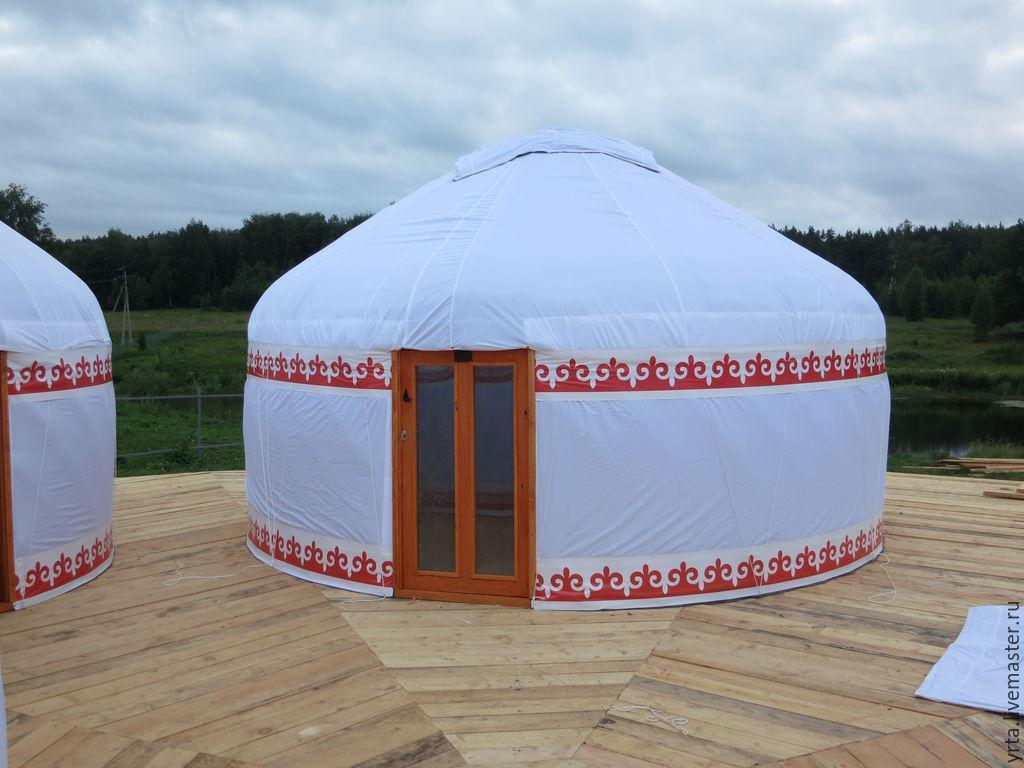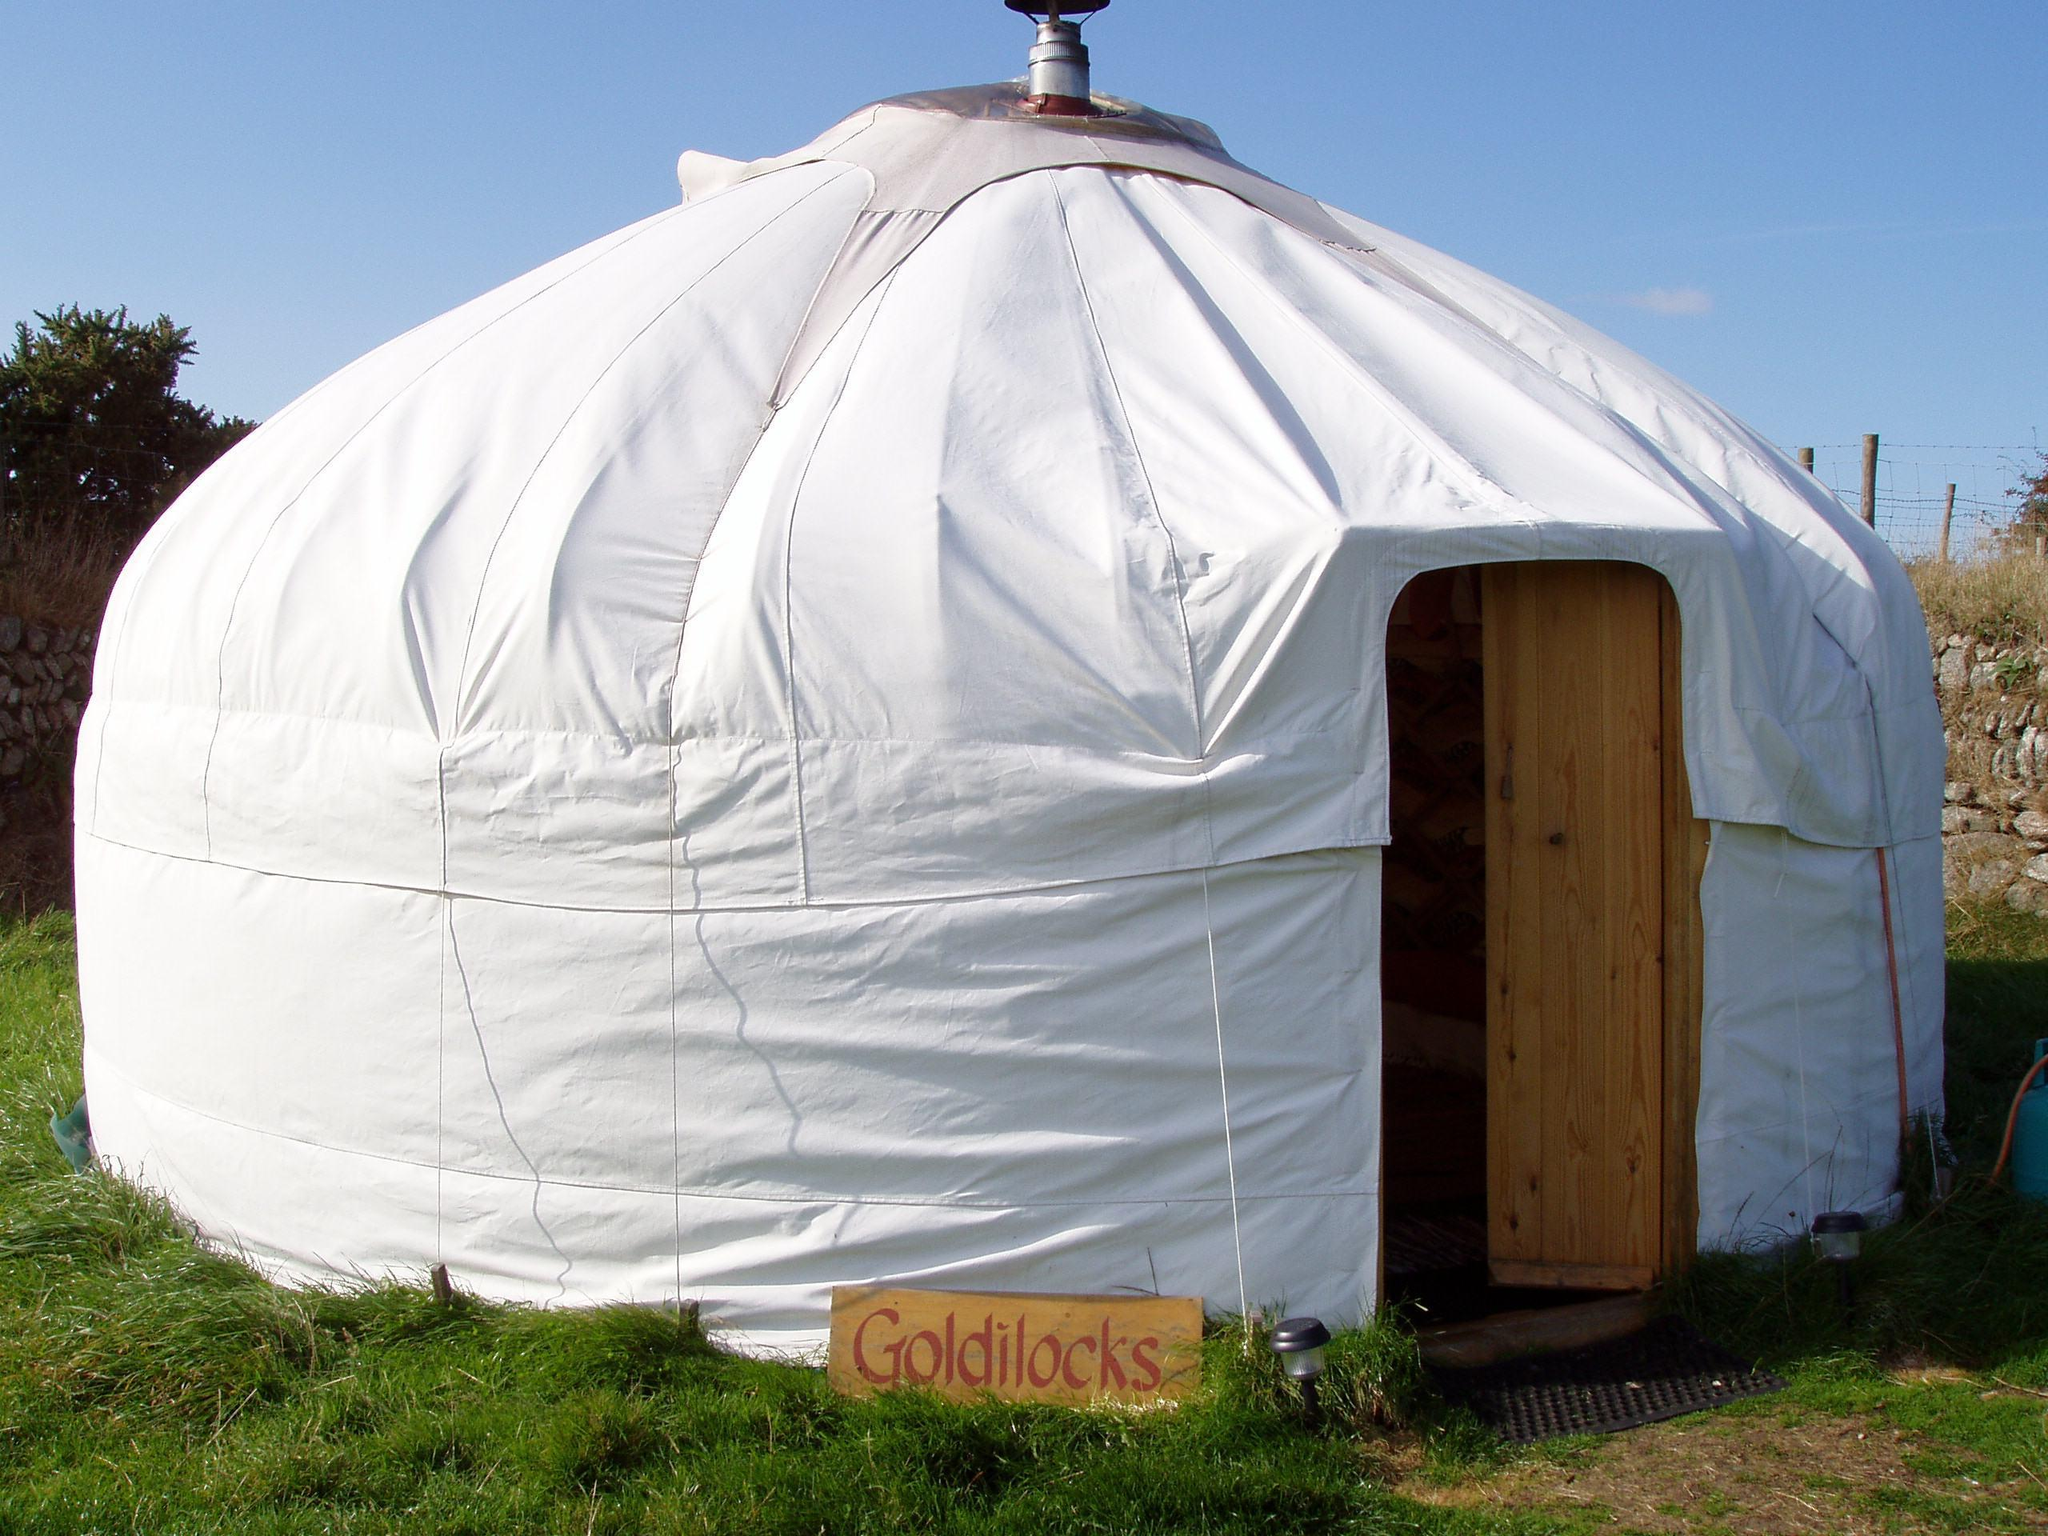The first image is the image on the left, the second image is the image on the right. Evaluate the accuracy of this statement regarding the images: "In one image, a yurt sits on a raised deck with wooden fencing, while the other image shows one or more yurts with outdoor table seating.". Is it true? Answer yes or no. No. The first image is the image on the left, the second image is the image on the right. Considering the images on both sides, is "The hut in the image on the right is set up on a deck." valid? Answer yes or no. No. 